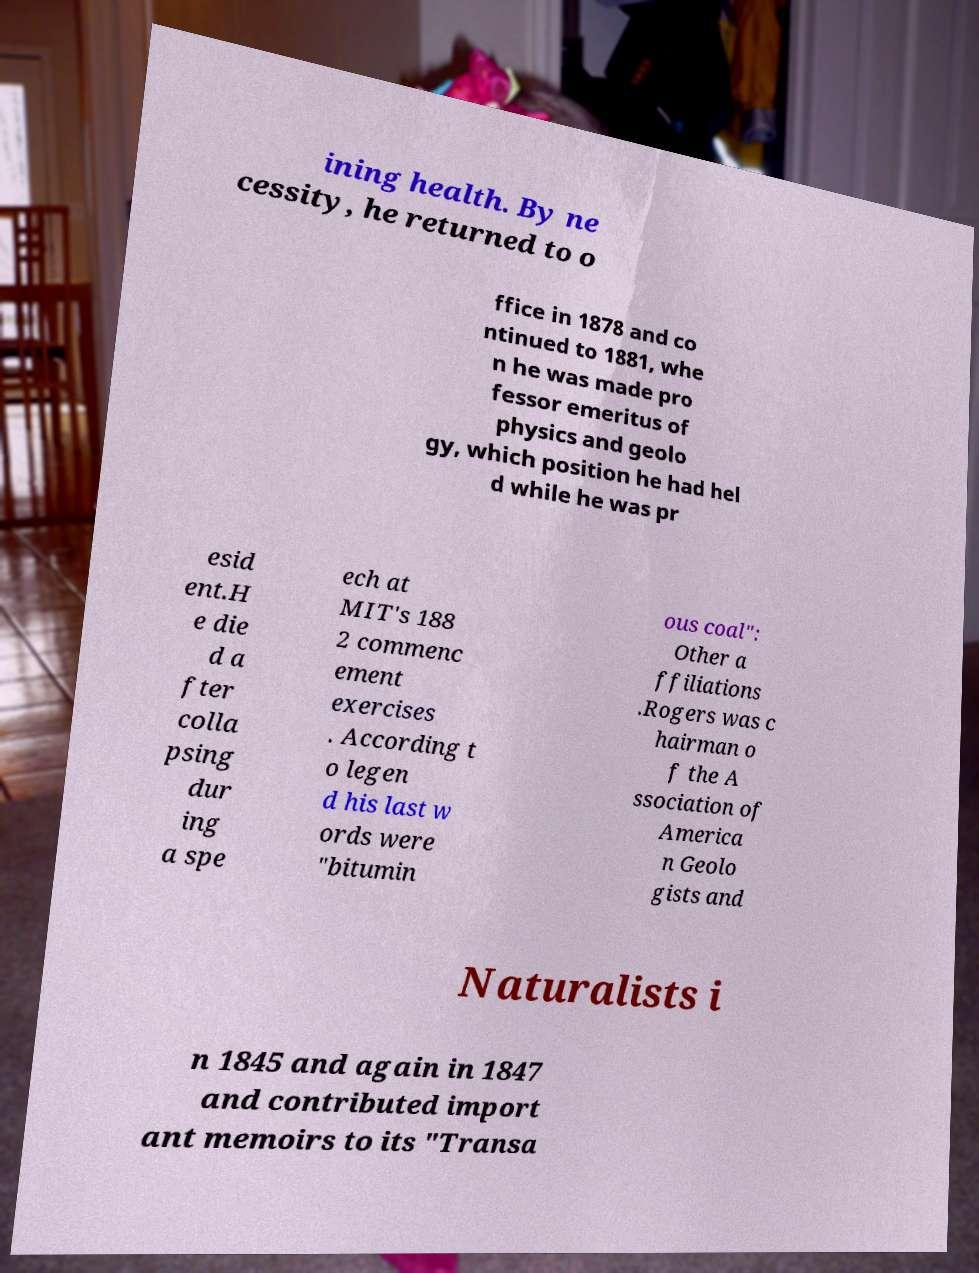Can you accurately transcribe the text from the provided image for me? ining health. By ne cessity, he returned to o ffice in 1878 and co ntinued to 1881, whe n he was made pro fessor emeritus of physics and geolo gy, which position he had hel d while he was pr esid ent.H e die d a fter colla psing dur ing a spe ech at MIT's 188 2 commenc ement exercises . According t o legen d his last w ords were "bitumin ous coal": Other a ffiliations .Rogers was c hairman o f the A ssociation of America n Geolo gists and Naturalists i n 1845 and again in 1847 and contributed import ant memoirs to its "Transa 